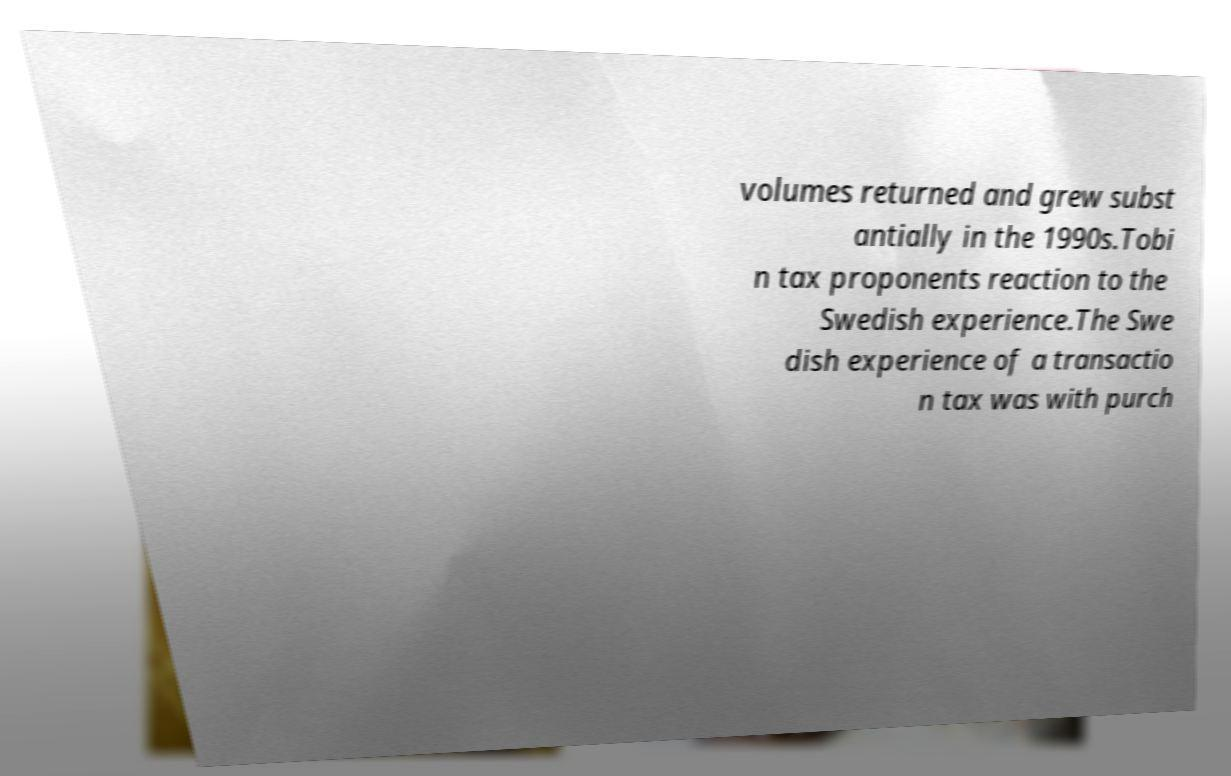I need the written content from this picture converted into text. Can you do that? volumes returned and grew subst antially in the 1990s.Tobi n tax proponents reaction to the Swedish experience.The Swe dish experience of a transactio n tax was with purch 